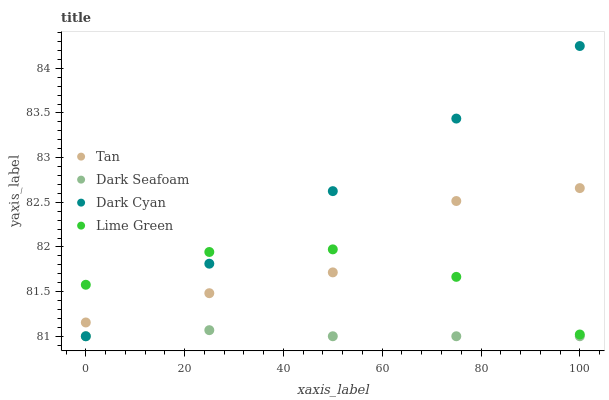Does Dark Seafoam have the minimum area under the curve?
Answer yes or no. Yes. Does Dark Cyan have the maximum area under the curve?
Answer yes or no. Yes. Does Tan have the minimum area under the curve?
Answer yes or no. No. Does Tan have the maximum area under the curve?
Answer yes or no. No. Is Dark Cyan the smoothest?
Answer yes or no. Yes. Is Tan the roughest?
Answer yes or no. Yes. Is Lime Green the smoothest?
Answer yes or no. No. Is Lime Green the roughest?
Answer yes or no. No. Does Dark Cyan have the lowest value?
Answer yes or no. Yes. Does Lime Green have the lowest value?
Answer yes or no. No. Does Dark Cyan have the highest value?
Answer yes or no. Yes. Does Tan have the highest value?
Answer yes or no. No. Is Dark Seafoam less than Lime Green?
Answer yes or no. Yes. Is Tan greater than Dark Seafoam?
Answer yes or no. Yes. Does Dark Cyan intersect Lime Green?
Answer yes or no. Yes. Is Dark Cyan less than Lime Green?
Answer yes or no. No. Is Dark Cyan greater than Lime Green?
Answer yes or no. No. Does Dark Seafoam intersect Lime Green?
Answer yes or no. No. 